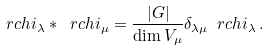<formula> <loc_0><loc_0><loc_500><loc_500>\ r c h i _ { \lambda } * \ r c h i _ { \mu } = \frac { | G | } { \dim V _ { \mu } } \delta _ { \lambda \mu } \ r c h i _ { \lambda } \, .</formula> 